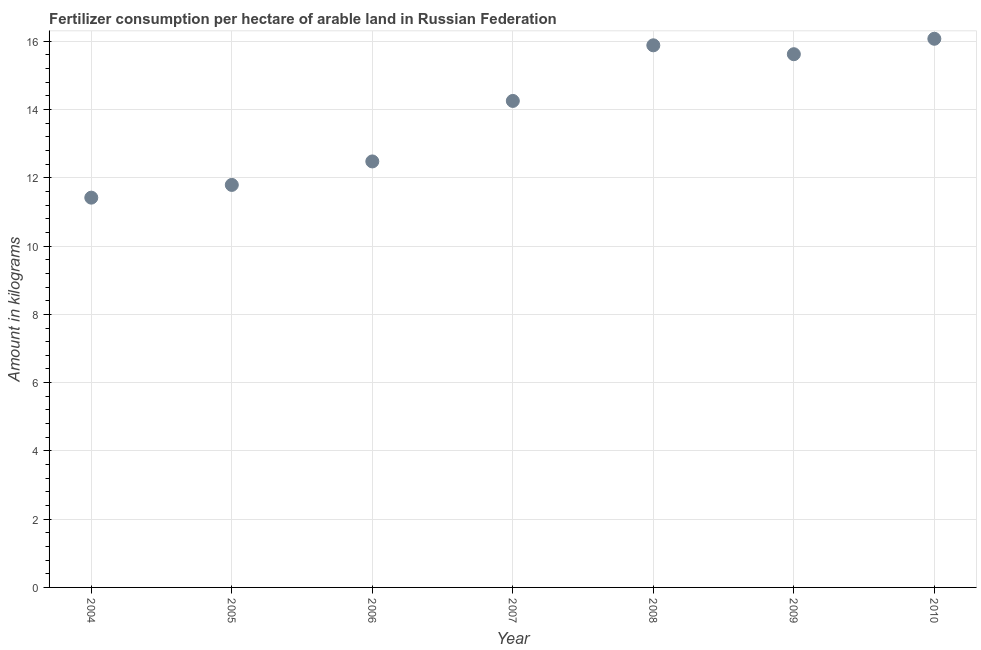What is the amount of fertilizer consumption in 2009?
Your answer should be compact. 15.62. Across all years, what is the maximum amount of fertilizer consumption?
Make the answer very short. 16.07. Across all years, what is the minimum amount of fertilizer consumption?
Provide a short and direct response. 11.42. What is the sum of the amount of fertilizer consumption?
Your answer should be compact. 97.53. What is the difference between the amount of fertilizer consumption in 2007 and 2009?
Ensure brevity in your answer.  -1.37. What is the average amount of fertilizer consumption per year?
Provide a short and direct response. 13.93. What is the median amount of fertilizer consumption?
Keep it short and to the point. 14.25. What is the ratio of the amount of fertilizer consumption in 2006 to that in 2010?
Provide a succinct answer. 0.78. Is the amount of fertilizer consumption in 2004 less than that in 2006?
Offer a terse response. Yes. Is the difference between the amount of fertilizer consumption in 2005 and 2008 greater than the difference between any two years?
Keep it short and to the point. No. What is the difference between the highest and the second highest amount of fertilizer consumption?
Offer a very short reply. 0.19. What is the difference between the highest and the lowest amount of fertilizer consumption?
Your answer should be very brief. 4.65. Does the amount of fertilizer consumption monotonically increase over the years?
Offer a very short reply. No. How many years are there in the graph?
Your answer should be compact. 7. Are the values on the major ticks of Y-axis written in scientific E-notation?
Make the answer very short. No. Does the graph contain grids?
Keep it short and to the point. Yes. What is the title of the graph?
Offer a terse response. Fertilizer consumption per hectare of arable land in Russian Federation . What is the label or title of the X-axis?
Provide a succinct answer. Year. What is the label or title of the Y-axis?
Offer a very short reply. Amount in kilograms. What is the Amount in kilograms in 2004?
Your answer should be compact. 11.42. What is the Amount in kilograms in 2005?
Your response must be concise. 11.79. What is the Amount in kilograms in 2006?
Make the answer very short. 12.48. What is the Amount in kilograms in 2007?
Your answer should be compact. 14.25. What is the Amount in kilograms in 2008?
Your answer should be very brief. 15.88. What is the Amount in kilograms in 2009?
Your answer should be very brief. 15.62. What is the Amount in kilograms in 2010?
Ensure brevity in your answer.  16.07. What is the difference between the Amount in kilograms in 2004 and 2005?
Keep it short and to the point. -0.37. What is the difference between the Amount in kilograms in 2004 and 2006?
Your answer should be very brief. -1.06. What is the difference between the Amount in kilograms in 2004 and 2007?
Provide a short and direct response. -2.83. What is the difference between the Amount in kilograms in 2004 and 2008?
Provide a succinct answer. -4.46. What is the difference between the Amount in kilograms in 2004 and 2009?
Offer a terse response. -4.2. What is the difference between the Amount in kilograms in 2004 and 2010?
Offer a terse response. -4.65. What is the difference between the Amount in kilograms in 2005 and 2006?
Keep it short and to the point. -0.69. What is the difference between the Amount in kilograms in 2005 and 2007?
Keep it short and to the point. -2.46. What is the difference between the Amount in kilograms in 2005 and 2008?
Provide a short and direct response. -4.09. What is the difference between the Amount in kilograms in 2005 and 2009?
Provide a short and direct response. -3.83. What is the difference between the Amount in kilograms in 2005 and 2010?
Give a very brief answer. -4.28. What is the difference between the Amount in kilograms in 2006 and 2007?
Your answer should be very brief. -1.77. What is the difference between the Amount in kilograms in 2006 and 2008?
Make the answer very short. -3.4. What is the difference between the Amount in kilograms in 2006 and 2009?
Keep it short and to the point. -3.14. What is the difference between the Amount in kilograms in 2006 and 2010?
Keep it short and to the point. -3.59. What is the difference between the Amount in kilograms in 2007 and 2008?
Keep it short and to the point. -1.63. What is the difference between the Amount in kilograms in 2007 and 2009?
Ensure brevity in your answer.  -1.37. What is the difference between the Amount in kilograms in 2007 and 2010?
Offer a very short reply. -1.82. What is the difference between the Amount in kilograms in 2008 and 2009?
Provide a short and direct response. 0.26. What is the difference between the Amount in kilograms in 2008 and 2010?
Ensure brevity in your answer.  -0.19. What is the difference between the Amount in kilograms in 2009 and 2010?
Offer a very short reply. -0.45. What is the ratio of the Amount in kilograms in 2004 to that in 2005?
Your answer should be compact. 0.97. What is the ratio of the Amount in kilograms in 2004 to that in 2006?
Your response must be concise. 0.92. What is the ratio of the Amount in kilograms in 2004 to that in 2007?
Offer a terse response. 0.8. What is the ratio of the Amount in kilograms in 2004 to that in 2008?
Provide a short and direct response. 0.72. What is the ratio of the Amount in kilograms in 2004 to that in 2009?
Your answer should be very brief. 0.73. What is the ratio of the Amount in kilograms in 2004 to that in 2010?
Give a very brief answer. 0.71. What is the ratio of the Amount in kilograms in 2005 to that in 2006?
Provide a succinct answer. 0.94. What is the ratio of the Amount in kilograms in 2005 to that in 2007?
Your answer should be very brief. 0.83. What is the ratio of the Amount in kilograms in 2005 to that in 2008?
Your answer should be compact. 0.74. What is the ratio of the Amount in kilograms in 2005 to that in 2009?
Provide a succinct answer. 0.76. What is the ratio of the Amount in kilograms in 2005 to that in 2010?
Offer a terse response. 0.73. What is the ratio of the Amount in kilograms in 2006 to that in 2007?
Keep it short and to the point. 0.88. What is the ratio of the Amount in kilograms in 2006 to that in 2008?
Provide a short and direct response. 0.79. What is the ratio of the Amount in kilograms in 2006 to that in 2009?
Keep it short and to the point. 0.8. What is the ratio of the Amount in kilograms in 2006 to that in 2010?
Keep it short and to the point. 0.78. What is the ratio of the Amount in kilograms in 2007 to that in 2008?
Provide a succinct answer. 0.9. What is the ratio of the Amount in kilograms in 2007 to that in 2009?
Your response must be concise. 0.91. What is the ratio of the Amount in kilograms in 2007 to that in 2010?
Ensure brevity in your answer.  0.89. What is the ratio of the Amount in kilograms in 2008 to that in 2009?
Offer a very short reply. 1.02. What is the ratio of the Amount in kilograms in 2008 to that in 2010?
Your answer should be very brief. 0.99. What is the ratio of the Amount in kilograms in 2009 to that in 2010?
Offer a very short reply. 0.97. 